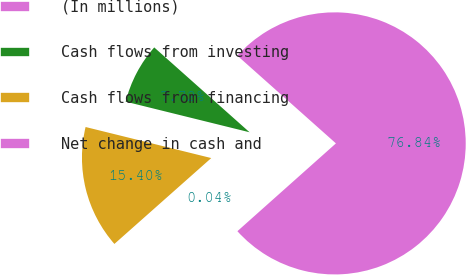Convert chart. <chart><loc_0><loc_0><loc_500><loc_500><pie_chart><fcel>(In millions)<fcel>Cash flows from investing<fcel>Cash flows from financing<fcel>Net change in cash and<nl><fcel>76.84%<fcel>7.72%<fcel>15.4%<fcel>0.04%<nl></chart> 